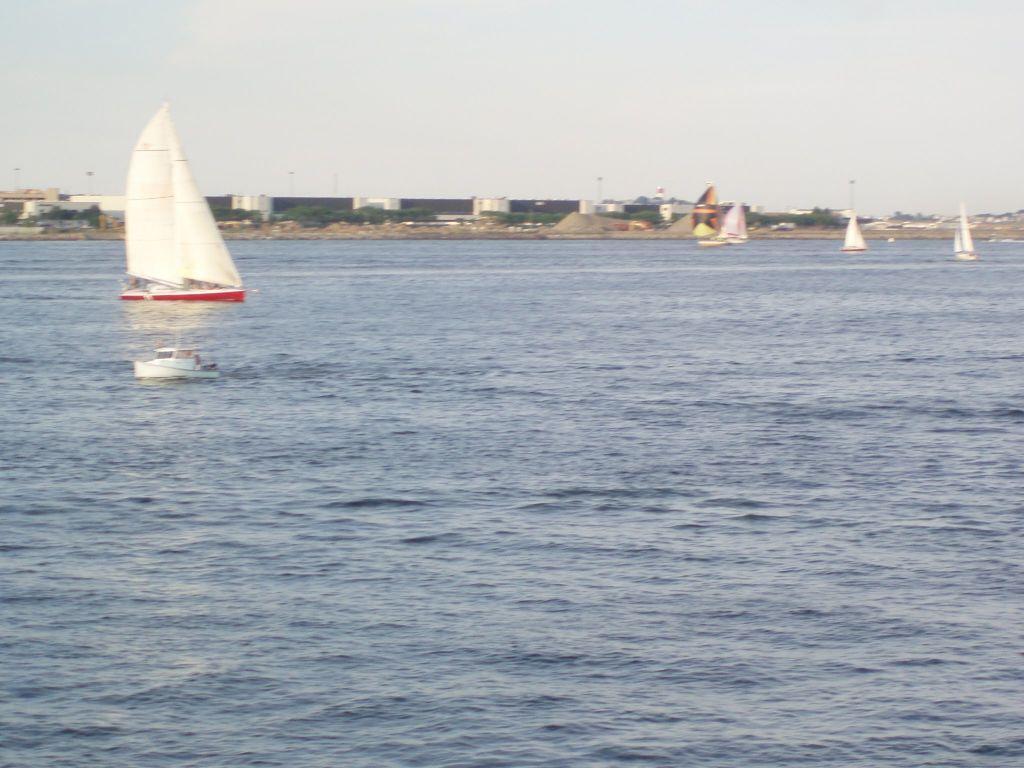In one or two sentences, can you explain what this image depicts? In this image we can see group of boats in the water. in the background, we can see a building and sky. 